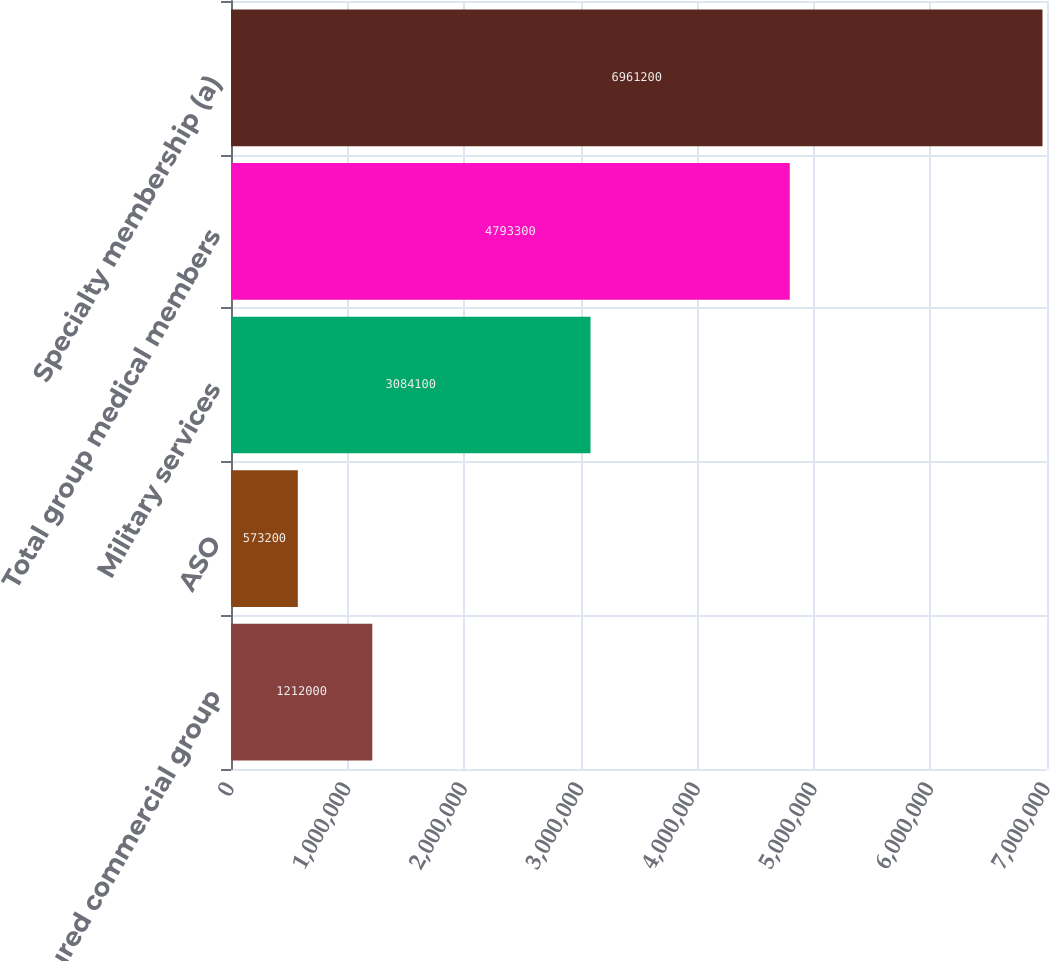<chart> <loc_0><loc_0><loc_500><loc_500><bar_chart><fcel>Fully-insured commercial group<fcel>ASO<fcel>Military services<fcel>Total group medical members<fcel>Specialty membership (a)<nl><fcel>1.212e+06<fcel>573200<fcel>3.0841e+06<fcel>4.7933e+06<fcel>6.9612e+06<nl></chart> 